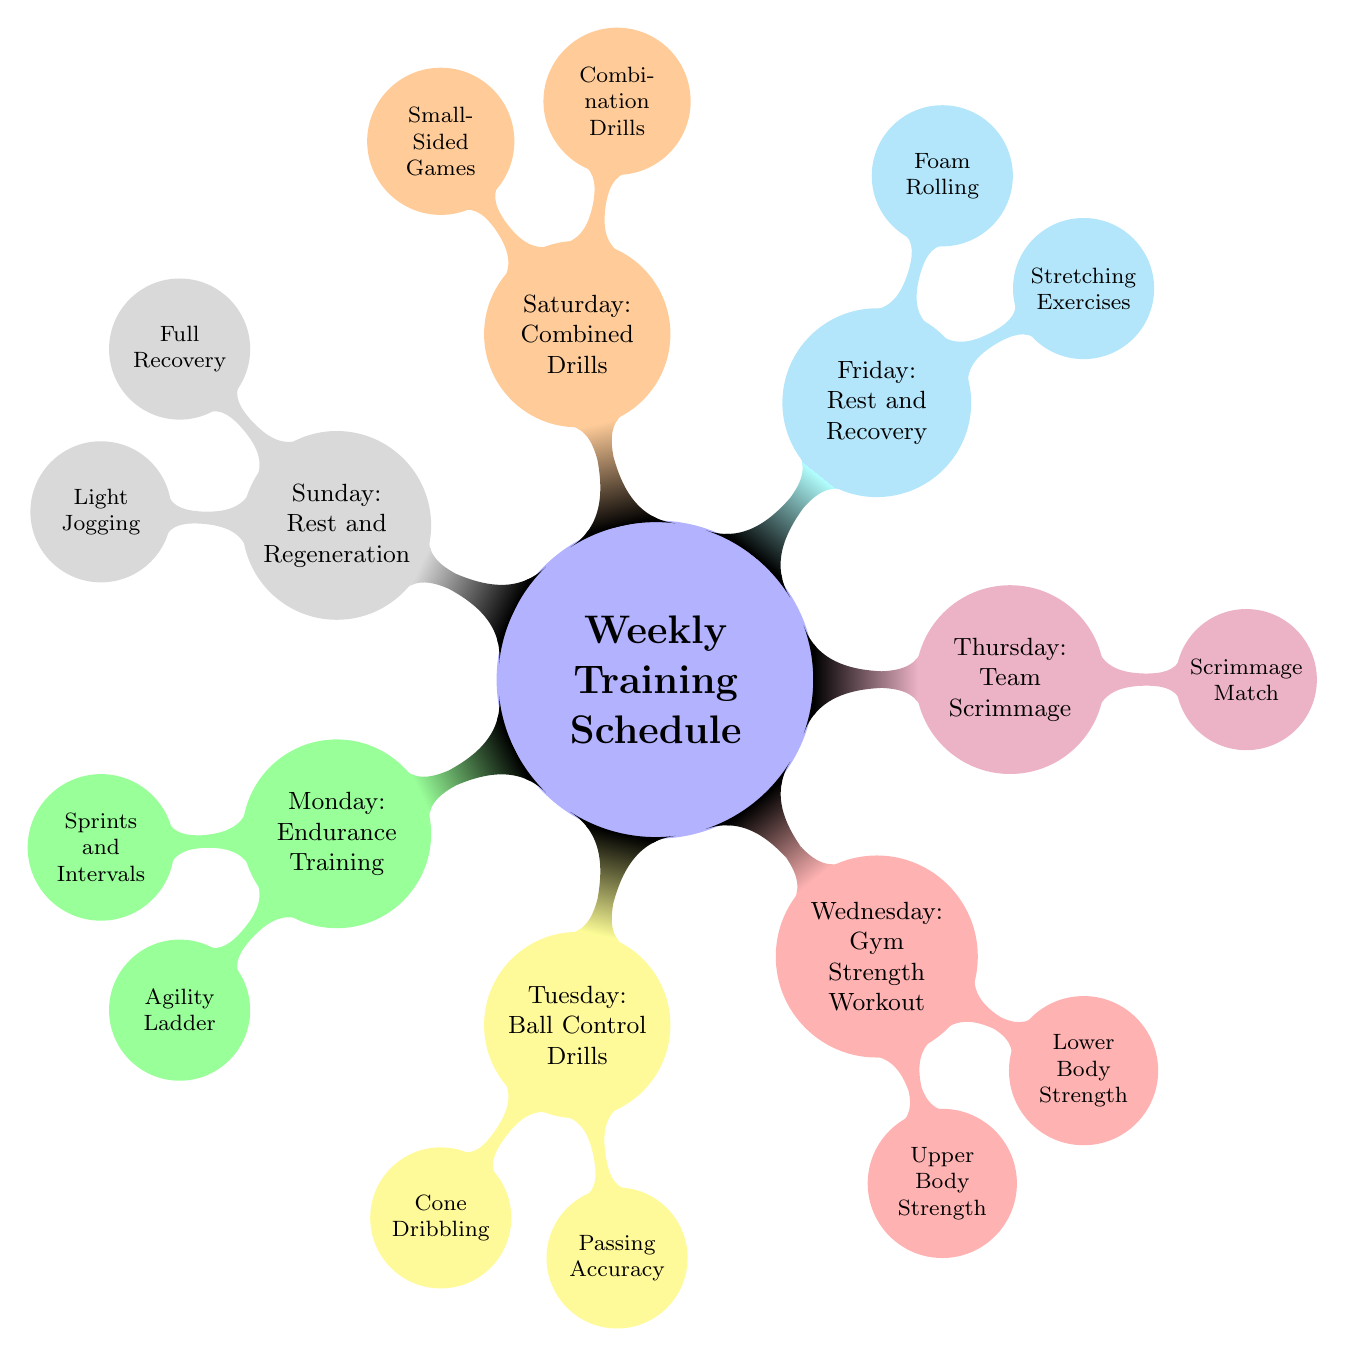What does Monday focus on? The diagram indicates that Monday is dedicated to Endurance Training, as stated in the first child node of the Weekly Training Schedule.
Answer: Endurance Training How many focus areas are outlined for Tuesday? The diagram shows two child nodes under Tuesday, which represent the focus areas for that day: Cone Dribbling and Passing Accuracy. Thus, there are two focus areas.
Answer: 2 What type of training is scheduled for Thursday? According to the diagram, Thursday is focused on Team Scrimmage, which is highlighted in the corresponding child node.
Answer: Team Scrimmage Which day has both stretching exercises and foam rolling? The diagram lists Rest and Recovery activities on Friday, under which both Stretching Exercises and Foam Rolling are mentioned as child nodes.
Answer: Friday Which two workout types are set for Wednesday? The diagram specifies that Wednesday includes Gym Strength Workout, with child nodes representing Upper Body Strength and Lower Body Strength, both of which are types of workouts for that day.
Answer: Upper Body Strength, Lower Body Strength What is the main activity listed for Saturday? The diagram indicates that Saturday focuses on Combined Drills, as stated in the main node for that day.
Answer: Combined Drills How many rest days are included in this training schedule? The diagram features two rest-related days: Friday (Rest and Recovery) and Sunday (Rest and Regeneration), indicating a total of two rest days.
Answer: 2 Which day features a scrimmage match? The diagram states that Thursday features a scrimmage match under the Team Scrimmage node.
Answer: Thursday What are the two activities listed for Sunday? According to the diagram, Sunday consists of two activities: Full Recovery and Light Jogging, both outlined under the Rest and Regeneration section.
Answer: Full Recovery, Light Jogging 